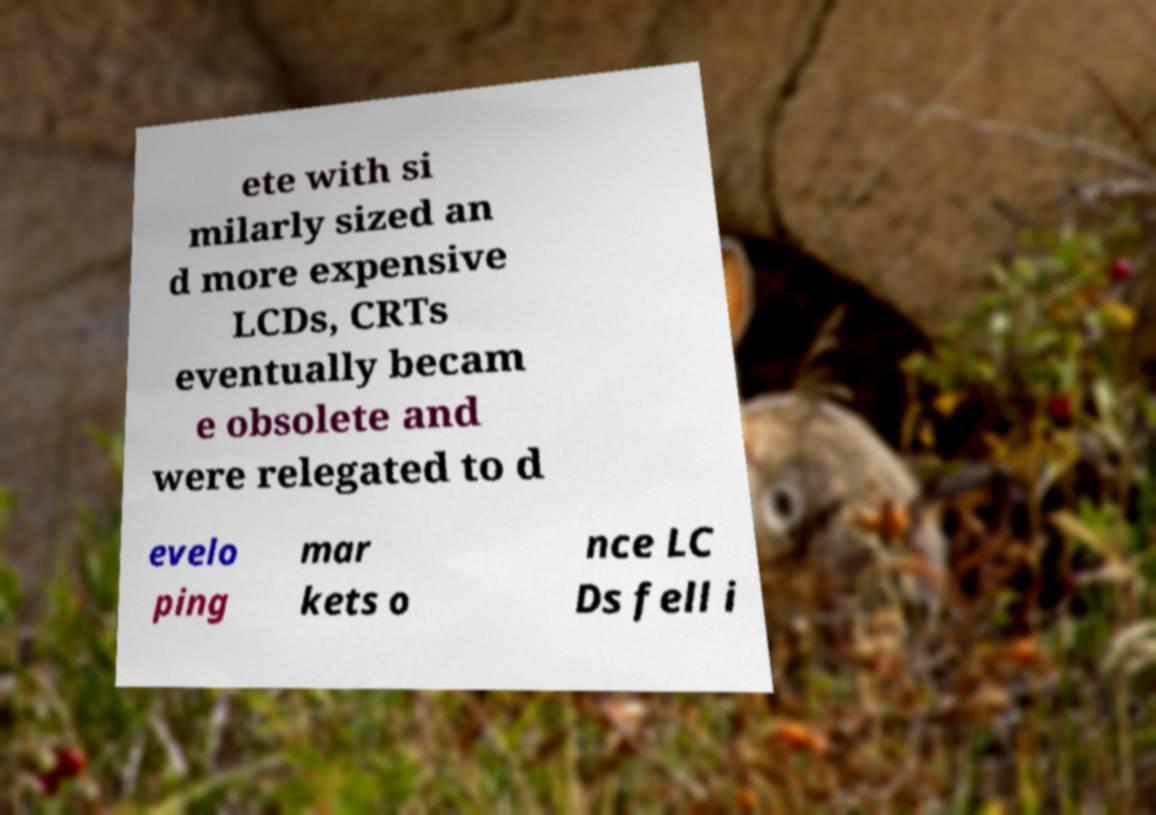Can you accurately transcribe the text from the provided image for me? ete with si milarly sized an d more expensive LCDs, CRTs eventually becam e obsolete and were relegated to d evelo ping mar kets o nce LC Ds fell i 